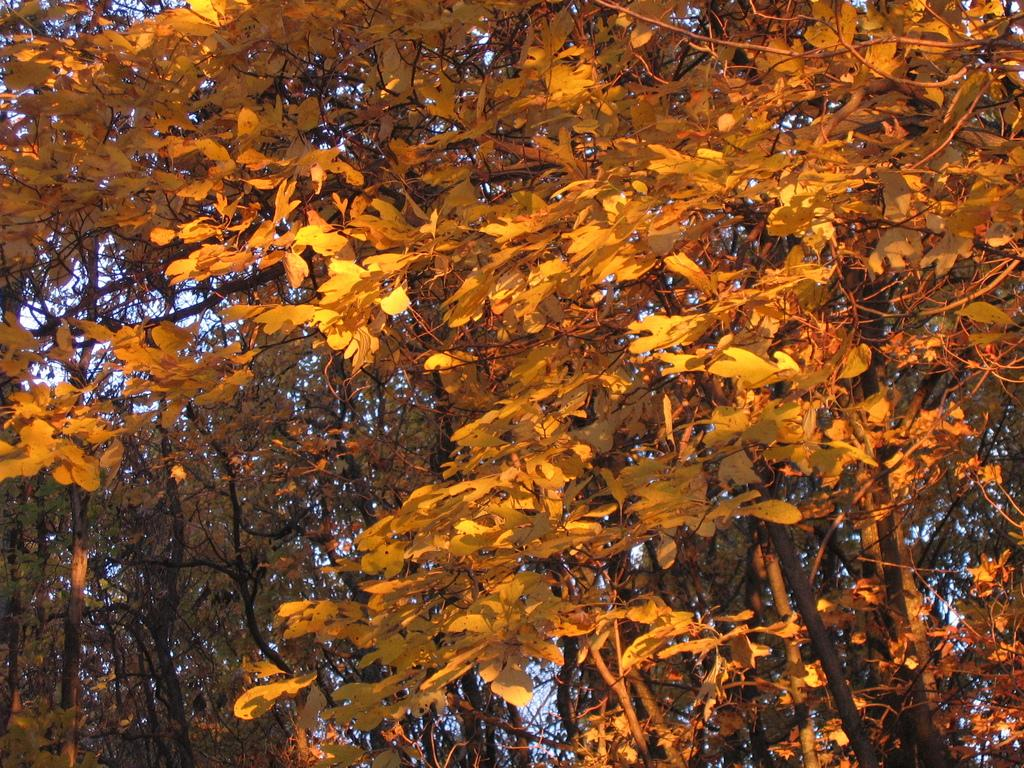What type of vegetation can be seen in the image? There are trees in the image. What part of the natural environment is visible in the image? The sky is visible in the background of the image. Where is the sink located in the image? There is no sink present in the image. What type of discussion is taking place in the image? There is no discussion taking place in the image; it only features trees and the sky. 